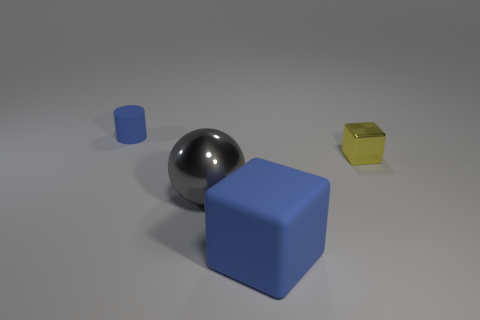Can you speculate on the purpose of this arrangement? The objects may have been arranged for a study of visual aesthetics or geometry. Each item’s distinct shape—sphere, cylinder, and cubes—and their varied materials could also be used in a physics education setting to explore concepts like reflection, transparency, and shadows. What might you infer about the lighting in this scene? The soft shadows and subtle reflection on the surfaces of the objects suggest a diffused light source, likely overhead. This lighting helps to accentuate the objects' dimensions and textures and helps to create a calm and controlled atmosphere. 